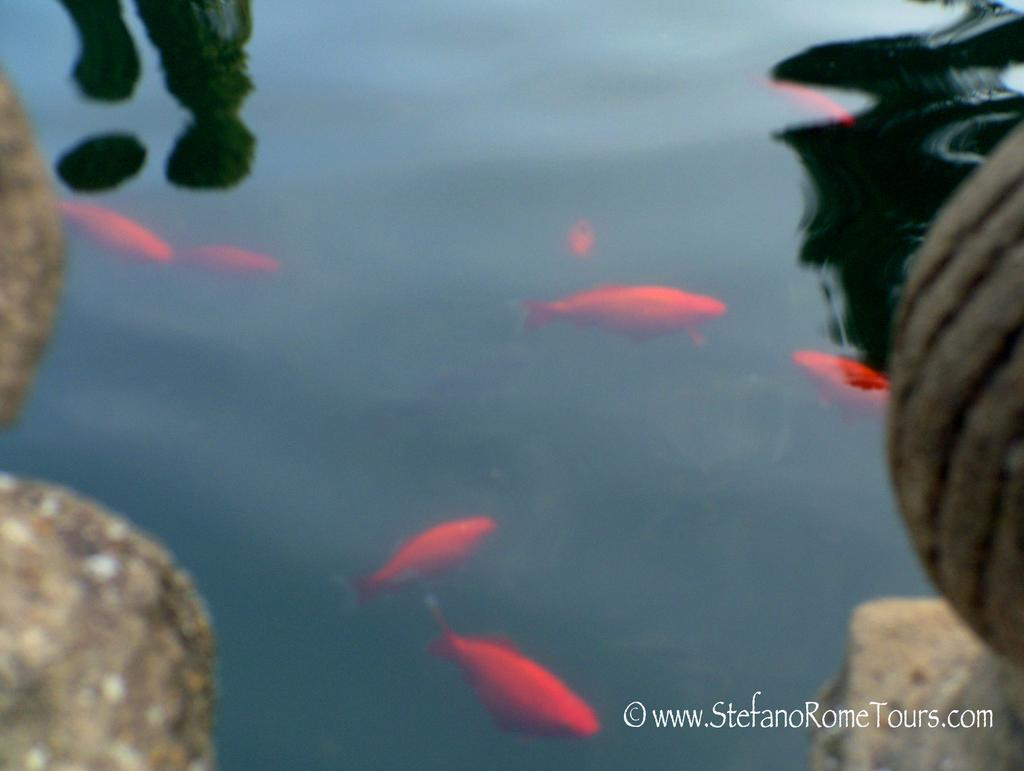What is the main subject of the image? The main subject of the image is a water body with fishes swimming in it. Are there any other objects or elements visible in the image? Yes, there are other objects visible in the image. Where can we find text in the image? The text is located in the bottom right corner of the image. Reasoning: Let's think step by following the guidelines to produce the conversation. We start by identifying the main subject of the image, which is the water body with fishes swimming in it. Then, we acknowledge the presence of other objects in the image without specifying what they are. Finally, we mention the location of the text in the image. Absurd Question/Answer: What type of news can be seen being delivered by the crow in the image? There is no crow or news present in the image. How is the whip being used in the image? There is no whip present in the image. 